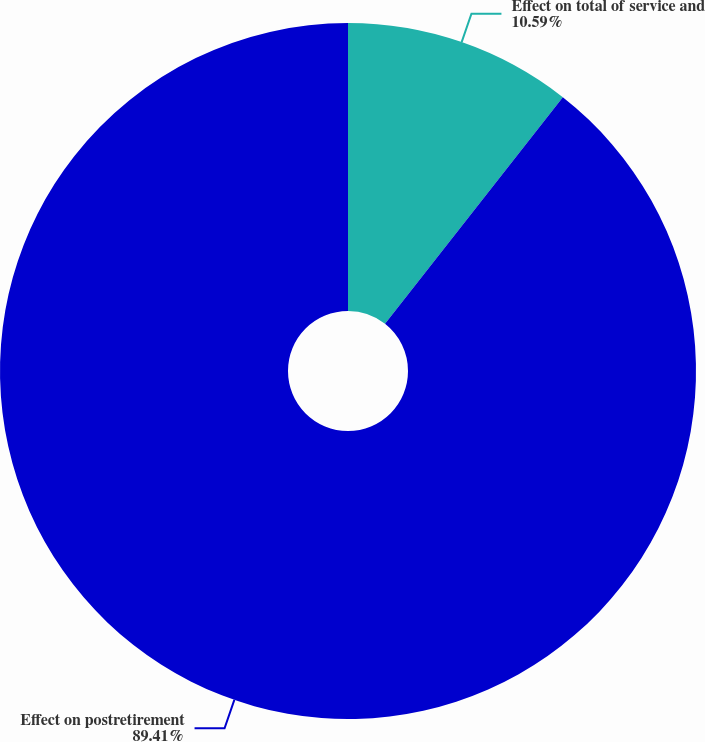Convert chart. <chart><loc_0><loc_0><loc_500><loc_500><pie_chart><fcel>Effect on total of service and<fcel>Effect on postretirement<nl><fcel>10.59%<fcel>89.41%<nl></chart> 